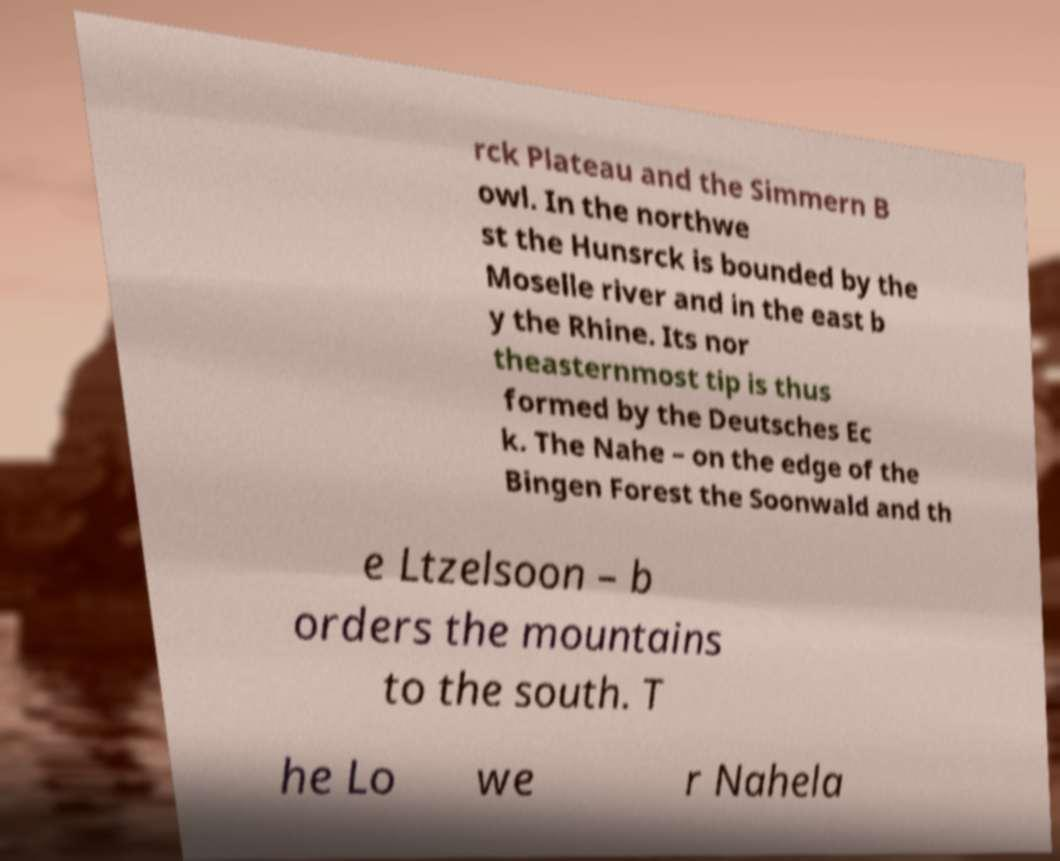Could you extract and type out the text from this image? rck Plateau and the Simmern B owl. In the northwe st the Hunsrck is bounded by the Moselle river and in the east b y the Rhine. Its nor theasternmost tip is thus formed by the Deutsches Ec k. The Nahe – on the edge of the Bingen Forest the Soonwald and th e Ltzelsoon – b orders the mountains to the south. T he Lo we r Nahela 